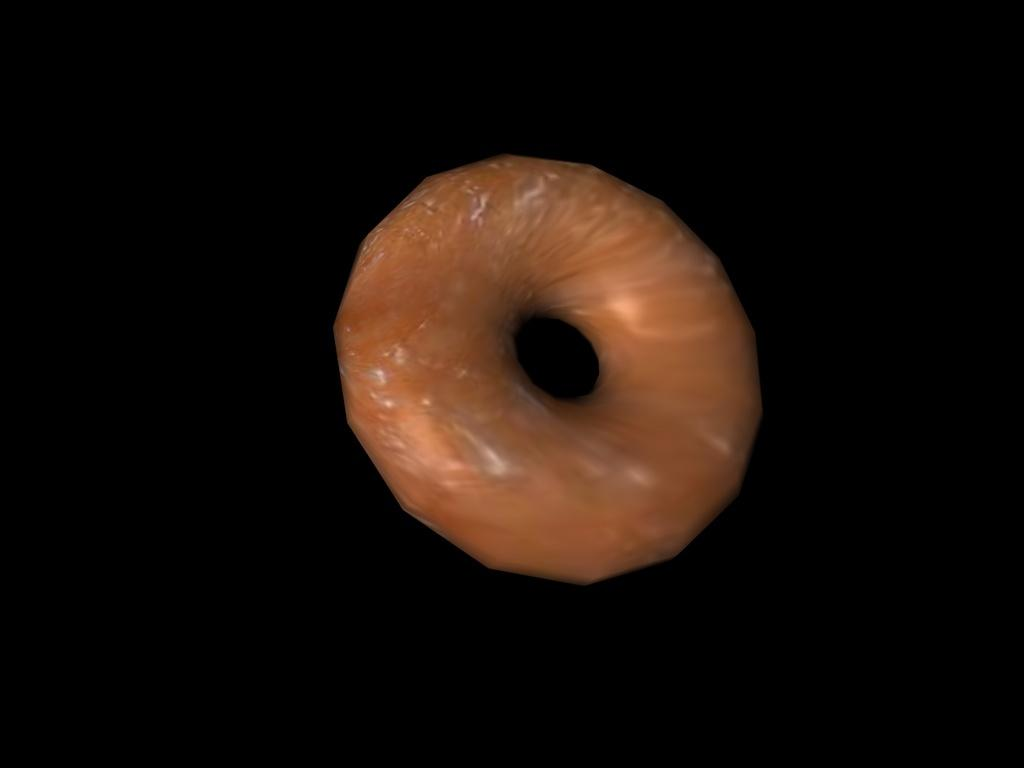What type of food is present in the image? There is a doughnut in the image. How many toads are sitting on the doughnut in the image? There are no toads present in the image; it features a doughnut. What message does the doughnut convey when saying good-bye in the image? The doughnut does not convey any message, as it is an inanimate object and cannot speak or communicate. 